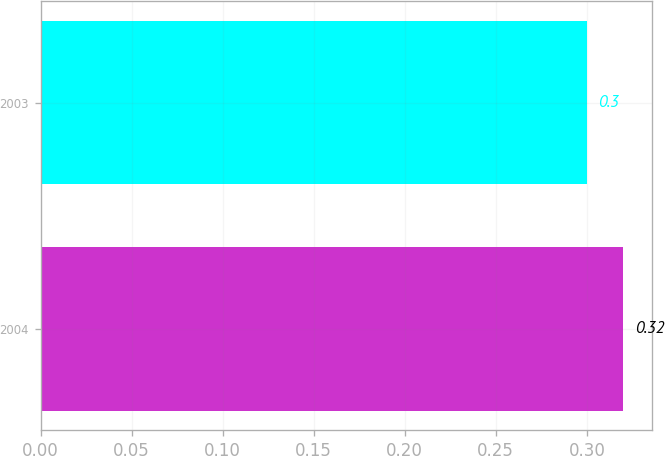Convert chart. <chart><loc_0><loc_0><loc_500><loc_500><bar_chart><fcel>2004<fcel>2003<nl><fcel>0.32<fcel>0.3<nl></chart> 